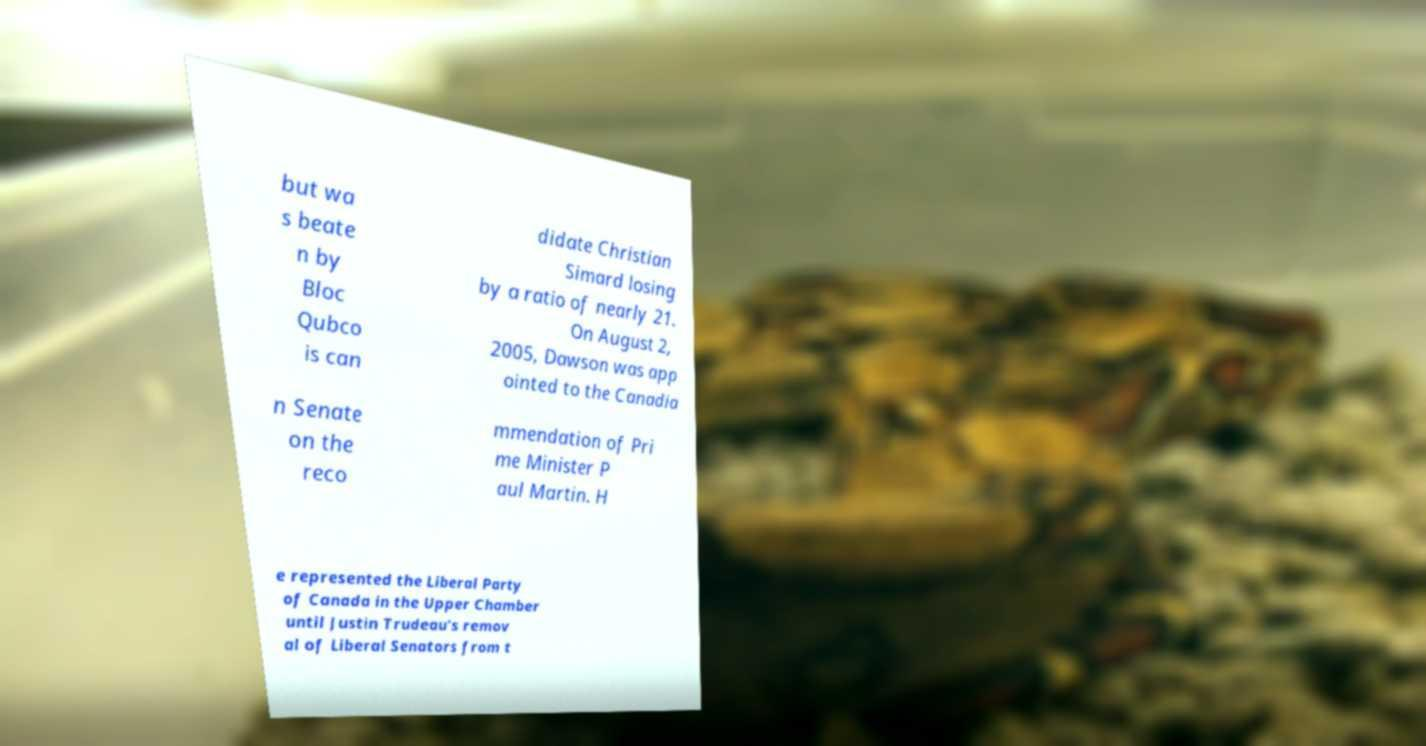I need the written content from this picture converted into text. Can you do that? but wa s beate n by Bloc Qubco is can didate Christian Simard losing by a ratio of nearly 21. On August 2, 2005, Dawson was app ointed to the Canadia n Senate on the reco mmendation of Pri me Minister P aul Martin. H e represented the Liberal Party of Canada in the Upper Chamber until Justin Trudeau's remov al of Liberal Senators from t 